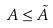<formula> <loc_0><loc_0><loc_500><loc_500>A \leq \tilde { A }</formula> 